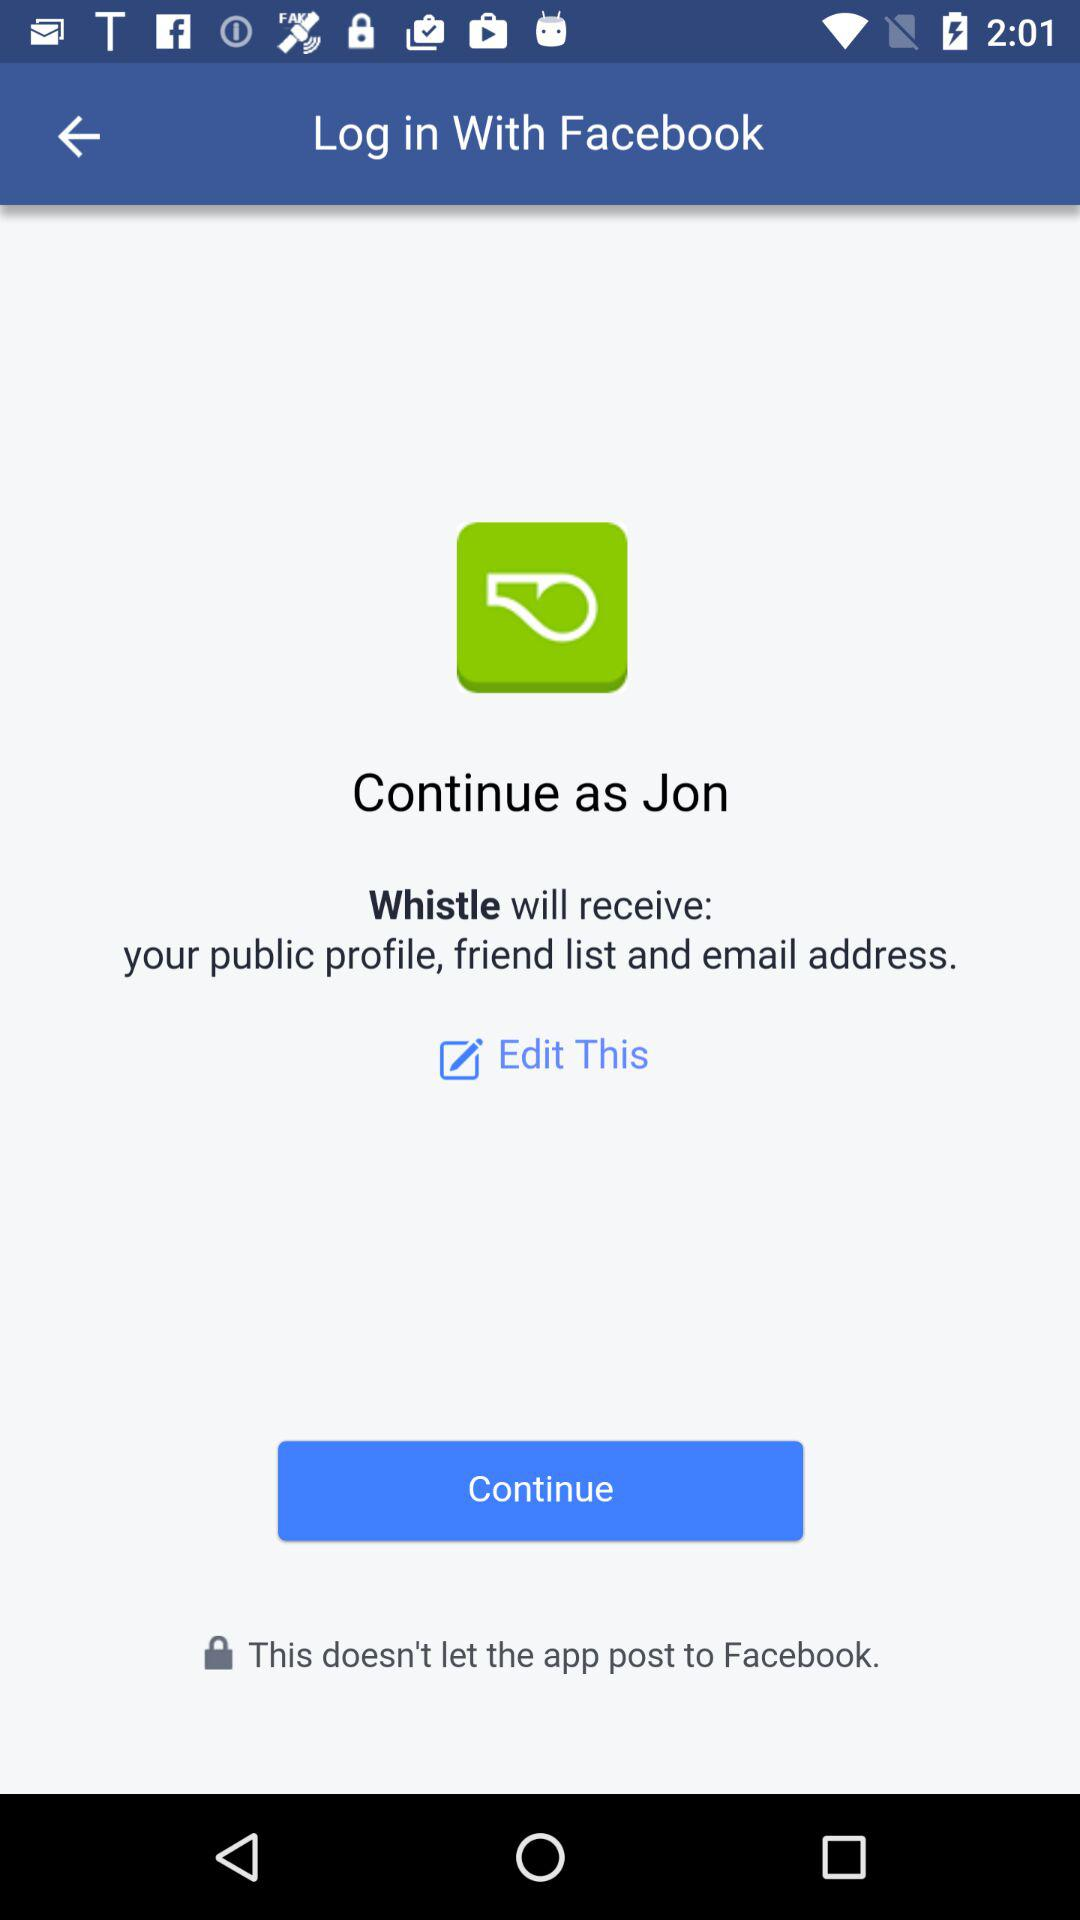Who will receive the public profile, friend list and email address? The public profile, friend list and email address will be received by "Whistle". 